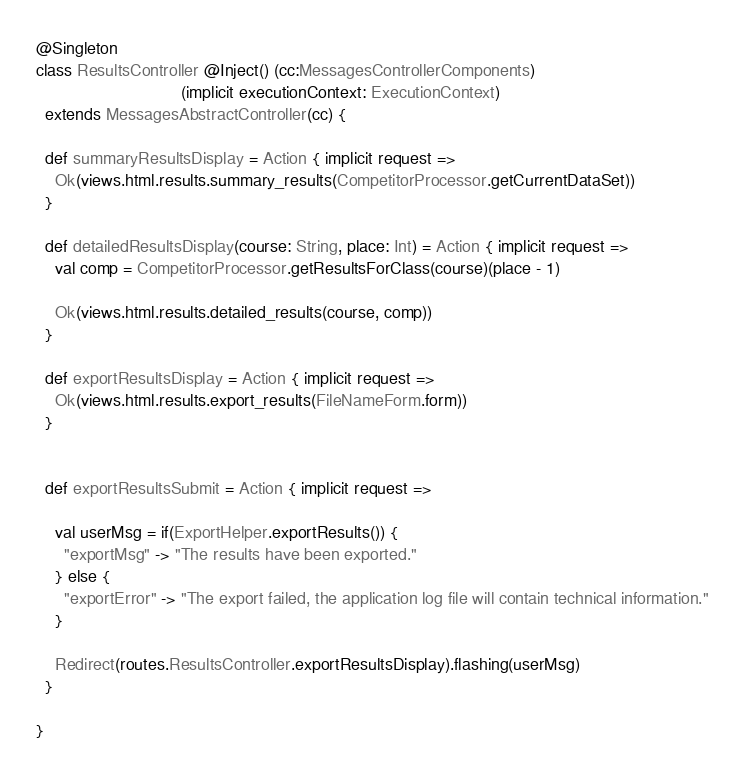<code> <loc_0><loc_0><loc_500><loc_500><_Scala_>@Singleton
class ResultsController @Inject() (cc:MessagesControllerComponents)
                               (implicit executionContext: ExecutionContext)
  extends MessagesAbstractController(cc) {

  def summaryResultsDisplay = Action { implicit request =>
    Ok(views.html.results.summary_results(CompetitorProcessor.getCurrentDataSet))
  }

  def detailedResultsDisplay(course: String, place: Int) = Action { implicit request =>
    val comp = CompetitorProcessor.getResultsForClass(course)(place - 1)

    Ok(views.html.results.detailed_results(course, comp))
  }

  def exportResultsDisplay = Action { implicit request =>
    Ok(views.html.results.export_results(FileNameForm.form))
  }


  def exportResultsSubmit = Action { implicit request =>

    val userMsg = if(ExportHelper.exportResults()) {
      "exportMsg" -> "The results have been exported."
    } else {
      "exportError" -> "The export failed, the application log file will contain technical information."
    }

    Redirect(routes.ResultsController.exportResultsDisplay).flashing(userMsg)
  }

}
</code> 